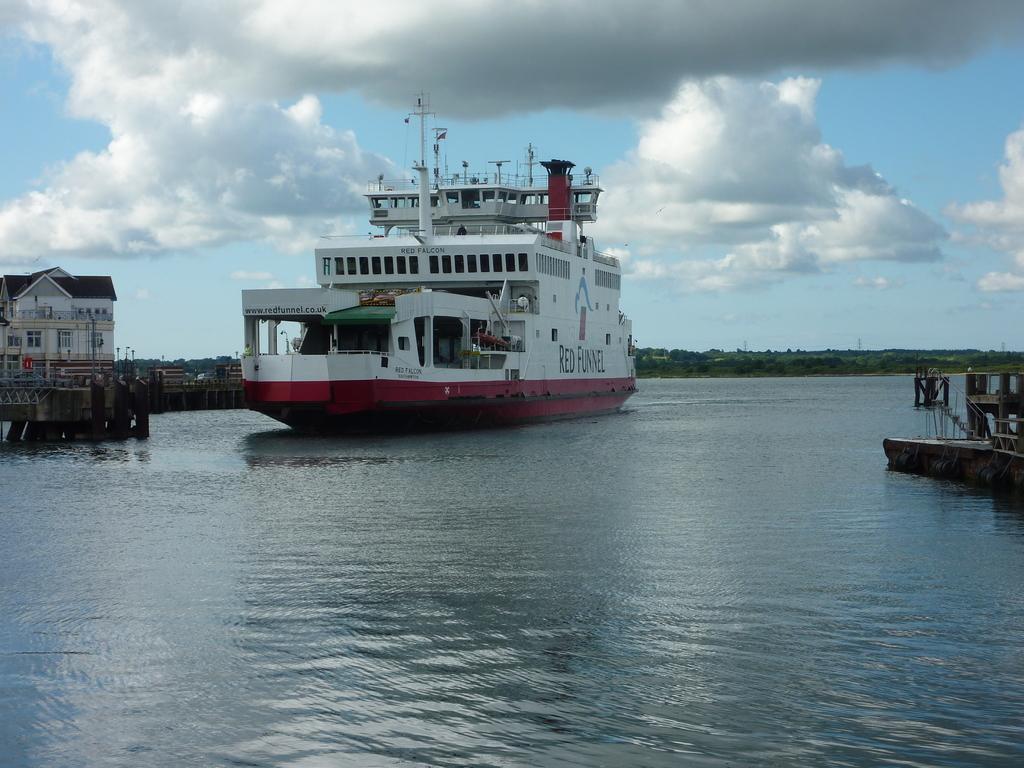Describe this image in one or two sentences. In this image we can see the ship on the water. And we can see the house and bridge with pillars. And at the back we can see there are trees and the cloudy sky. 